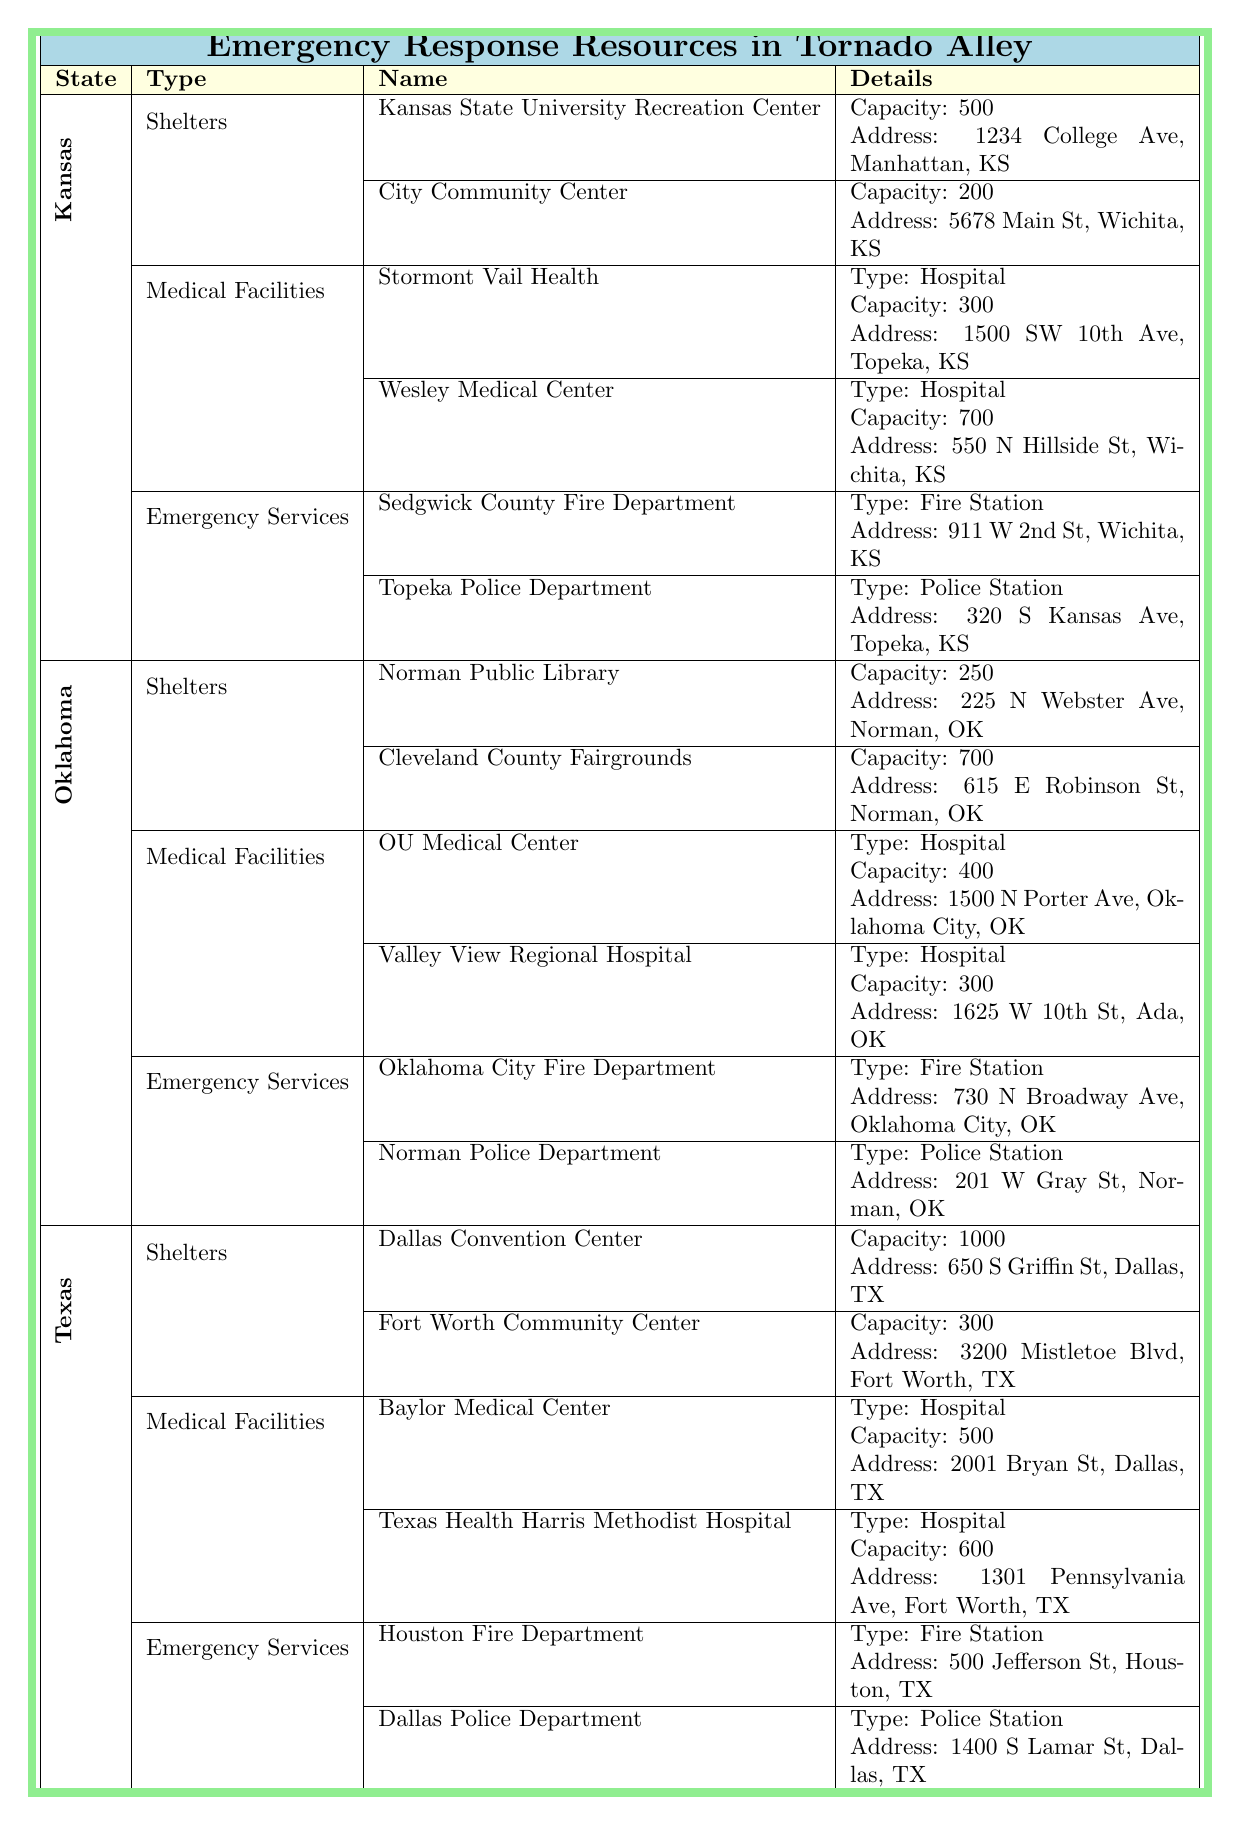What is the capacity of the Kansas State University Recreation Center? The table lists the Kansas State University Recreation Center under Kansas in the Shelters section, and indicates its capacity as 500.
Answer: 500 How many emergency services are listed for Oklahoma? For Oklahoma, there are two entries under the Emergency Services category: Oklahoma City Fire Department and Norman Police Department, totaling two emergency services.
Answer: 2 Which state has the highest capacity shelter? Among the shelters listed, Texas has the Dallas Convention Center with the highest capacity of 1000, thus making it the state with the highest capacity shelter.
Answer: Texas What is the total capacity of all medical facilities in Kansas? In Kansas, the two medical facilities listed are Stormont Vail Health (capacity 300) and Wesley Medical Center (capacity 700). Adding these capacities gives 300 + 700 = 1000.
Answer: 1000 Is there a police station listed in Texas? Yes, the table shows that the Dallas Police Department is listed under Emergency Services for Texas, confirming that there is a police station.
Answer: Yes Which location has more capacity: Cleveland County Fairgrounds in Oklahoma or City Community Center in Kansas? Cleveland County Fairgrounds in Oklahoma has a capacity of 700, while the City Community Center in Kansas has a capacity of 200. Comparing, 700 (Oklahoma) is greater than 200 (Kansas), meaning Cleveland County Fairgrounds has more capacity.
Answer: Cleveland County Fairgrounds What is the address of the Wesley Medical Center? The Wesley Medical Center is listed under Medical Facilities in Kansas and has its address provided as 550 N Hillside St, Wichita, KS.
Answer: 550 N Hillside St, Wichita, KS How many medical facilities are in Texas, and what are their names? Texas has two medical facilities listed: Baylor Medical Center and Texas Health Harris Methodist Hospital, which means there are two facilities in total.
Answer: 2 (Baylor Medical Center, Texas Health Harris Methodist Hospital) What is the difference in capacity between the largest shelter in Kansas and the largest shelter in Oklahoma? The largest shelter in Kansas is Kansas State University Recreation Center with a capacity of 500, while in Oklahoma, the Cleveland County Fairgrounds has a capacity of 700. The difference in capacity is calculated as 700 - 500 = 200.
Answer: 200 